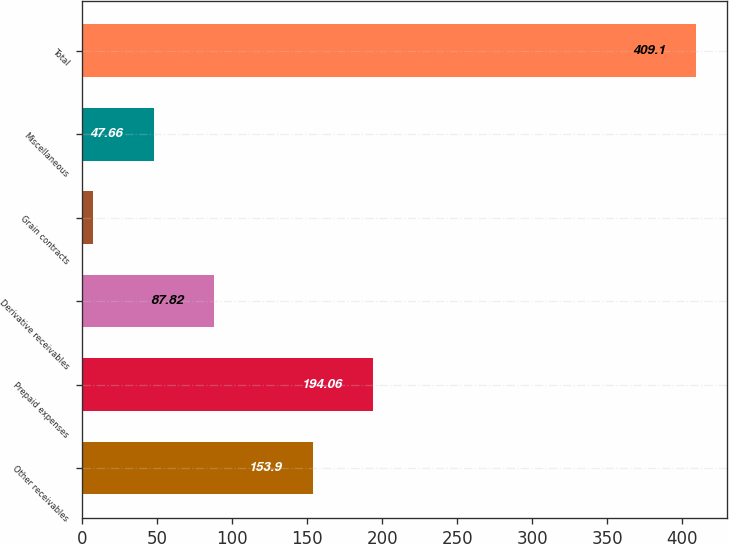<chart> <loc_0><loc_0><loc_500><loc_500><bar_chart><fcel>Other receivables<fcel>Prepaid expenses<fcel>Derivative receivables<fcel>Grain contracts<fcel>Miscellaneous<fcel>Total<nl><fcel>153.9<fcel>194.06<fcel>87.82<fcel>7.5<fcel>47.66<fcel>409.1<nl></chart> 